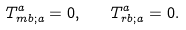Convert formula to latex. <formula><loc_0><loc_0><loc_500><loc_500>T _ { m b ; a } ^ { a } = 0 , \quad T _ { r b ; a } ^ { a } = 0 .</formula> 